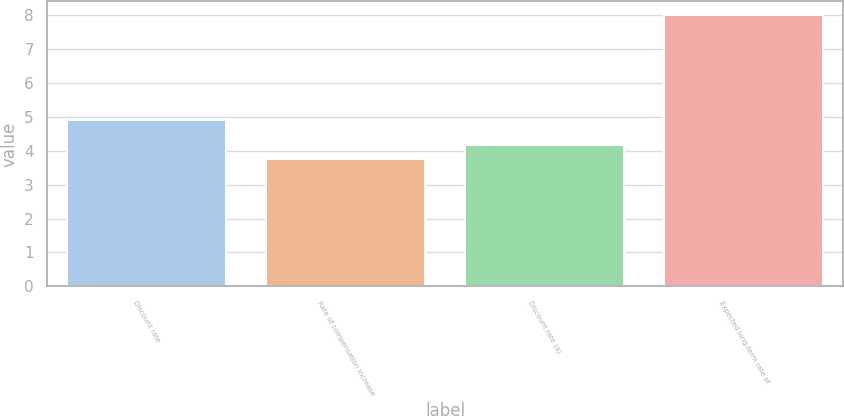Convert chart. <chart><loc_0><loc_0><loc_500><loc_500><bar_chart><fcel>Discount rate<fcel>Rate of compensation increase<fcel>Discount rate (a)<fcel>Expected long-term rate of<nl><fcel>4.9<fcel>3.75<fcel>4.17<fcel>8<nl></chart> 